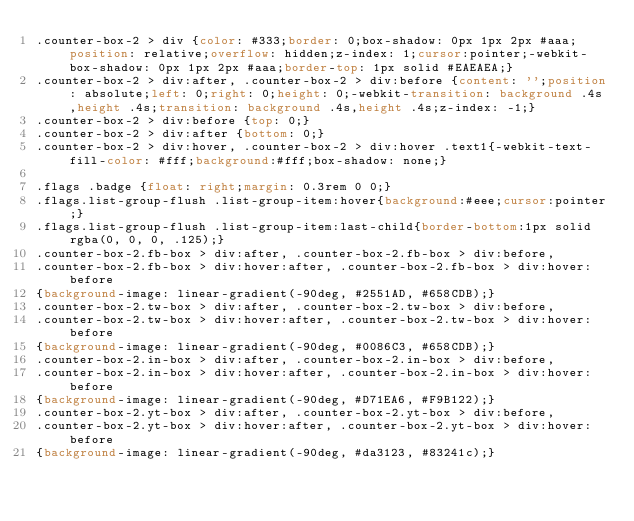<code> <loc_0><loc_0><loc_500><loc_500><_CSS_>.counter-box-2 > div {color: #333;border: 0;box-shadow: 0px 1px 2px #aaa;position: relative;overflow: hidden;z-index: 1;cursor:pointer;-webkit-box-shadow: 0px 1px 2px #aaa;border-top: 1px solid #EAEAEA;}
.counter-box-2 > div:after, .counter-box-2 > div:before {content: '';position: absolute;left: 0;right: 0;height: 0;-webkit-transition: background .4s,height .4s;transition: background .4s,height .4s;z-index: -1;}
.counter-box-2 > div:before {top: 0;}
.counter-box-2 > div:after {bottom: 0;}
.counter-box-2 > div:hover, .counter-box-2 > div:hover .text1{-webkit-text-fill-color: #fff;background:#fff;box-shadow: none;}

.flags .badge {float: right;margin: 0.3rem 0 0;}
.flags.list-group-flush .list-group-item:hover{background:#eee;cursor:pointer;}
.flags.list-group-flush .list-group-item:last-child{border-bottom:1px solid rgba(0, 0, 0, .125);}
.counter-box-2.fb-box > div:after, .counter-box-2.fb-box > div:before,
.counter-box-2.fb-box > div:hover:after, .counter-box-2.fb-box > div:hover:before
{background-image: linear-gradient(-90deg, #2551AD, #658CDB);} 
.counter-box-2.tw-box > div:after, .counter-box-2.tw-box > div:before,
.counter-box-2.tw-box > div:hover:after, .counter-box-2.tw-box > div:hover:before
{background-image: linear-gradient(-90deg, #0086C3, #658CDB);}
.counter-box-2.in-box > div:after, .counter-box-2.in-box > div:before,
.counter-box-2.in-box > div:hover:after, .counter-box-2.in-box > div:hover:before 
{background-image: linear-gradient(-90deg, #D71EA6, #F9B122);}
.counter-box-2.yt-box > div:after, .counter-box-2.yt-box > div:before,
.counter-box-2.yt-box > div:hover:after, .counter-box-2.yt-box > div:hover:before
{background-image: linear-gradient(-90deg, #da3123, #83241c);}</code> 